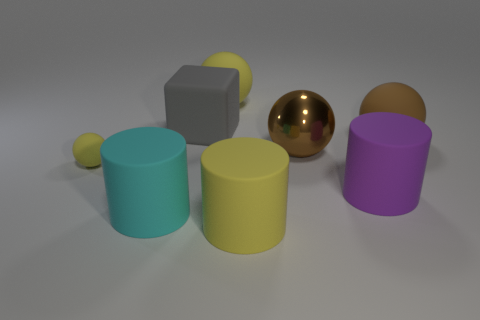How many cyan metallic balls are the same size as the brown metal object?
Offer a very short reply. 0. There is a rubber thing that is the same color as the large metal ball; what is its size?
Ensure brevity in your answer.  Large. What size is the rubber ball that is to the left of the brown matte object and in front of the large gray matte cube?
Your answer should be compact. Small. What number of matte objects are behind the big yellow matte thing in front of the brown sphere behind the large brown shiny object?
Offer a terse response. 6. Is there a rubber thing that has the same color as the metal thing?
Provide a succinct answer. Yes. There is a block that is the same size as the cyan matte cylinder; what is its color?
Offer a very short reply. Gray. The large yellow matte thing to the left of the big yellow rubber thing that is in front of the large brown ball that is on the left side of the purple rubber thing is what shape?
Provide a succinct answer. Sphere. There is a yellow matte thing behind the small yellow matte thing; what number of gray rubber things are behind it?
Your answer should be compact. 0. There is a yellow thing to the left of the large yellow ball; is it the same shape as the large yellow object that is behind the large brown rubber sphere?
Give a very brief answer. Yes. What number of gray rubber cubes are left of the purple rubber thing?
Offer a very short reply. 1. 